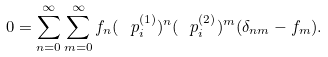Convert formula to latex. <formula><loc_0><loc_0><loc_500><loc_500>0 = \sum _ { n = 0 } ^ { \infty } \sum _ { m = 0 } ^ { \infty } f _ { n } ( \text { } p _ { i } ^ { ( 1 ) } ) ^ { n } ( \text { } p _ { i } ^ { ( 2 ) } ) ^ { m } ( \delta _ { n m } - f _ { m } ) .</formula> 